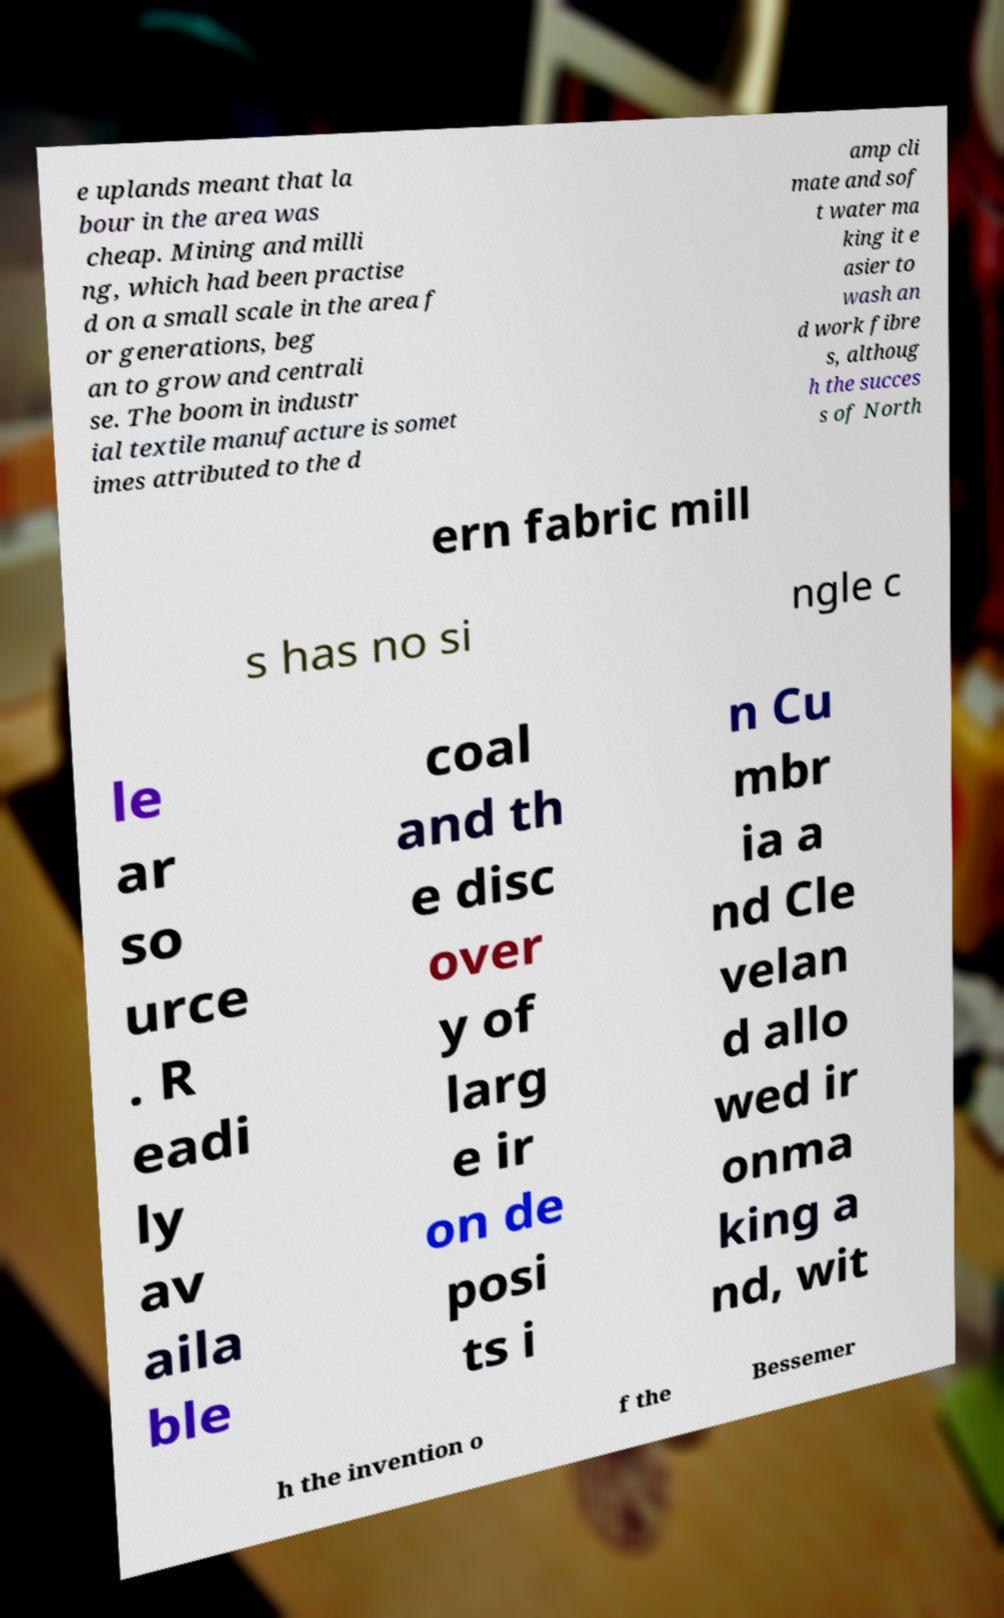There's text embedded in this image that I need extracted. Can you transcribe it verbatim? e uplands meant that la bour in the area was cheap. Mining and milli ng, which had been practise d on a small scale in the area f or generations, beg an to grow and centrali se. The boom in industr ial textile manufacture is somet imes attributed to the d amp cli mate and sof t water ma king it e asier to wash an d work fibre s, althoug h the succes s of North ern fabric mill s has no si ngle c le ar so urce . R eadi ly av aila ble coal and th e disc over y of larg e ir on de posi ts i n Cu mbr ia a nd Cle velan d allo wed ir onma king a nd, wit h the invention o f the Bessemer 